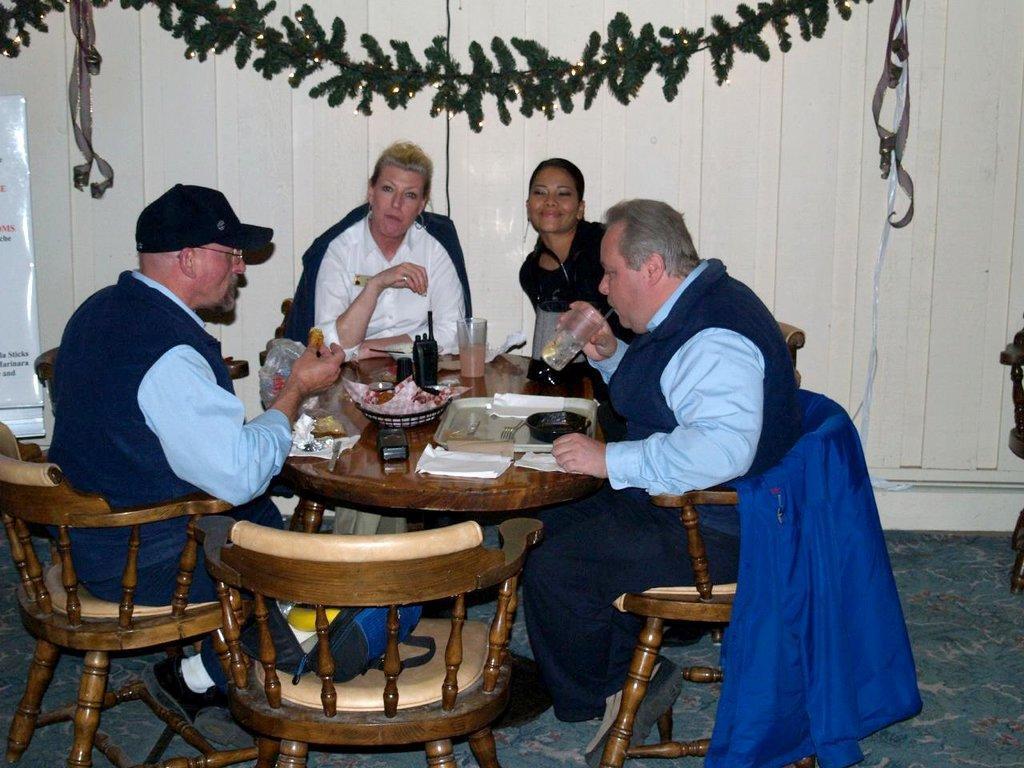In one or two sentences, can you explain what this image depicts? This picture is clicked inside a room. There are four people sitting on chairs at the table. There is a mobile phone, a Walkie-talkie, glasses, bowls, food, tray and spoons on the table. There is a jacket spread on the chair. On the other chair there is bag. To the left corner there is a board. In the background there is wall and a decorative item hanging on the wall.  